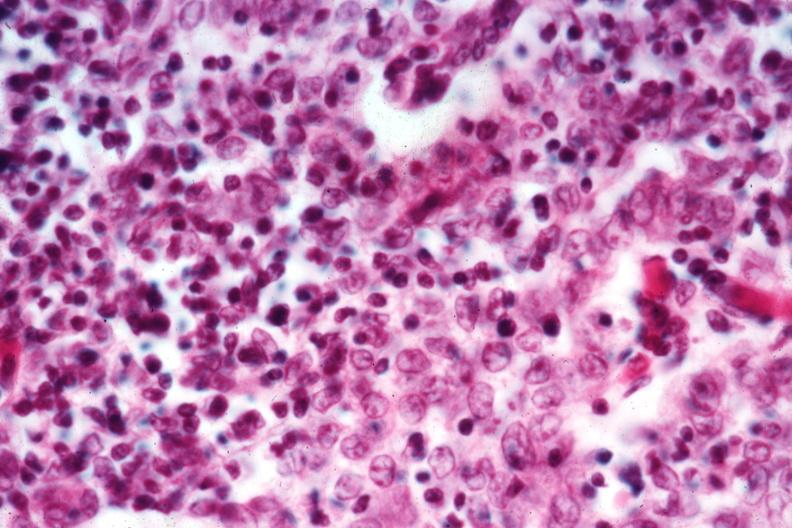s vessel present?
Answer the question using a single word or phrase. No 